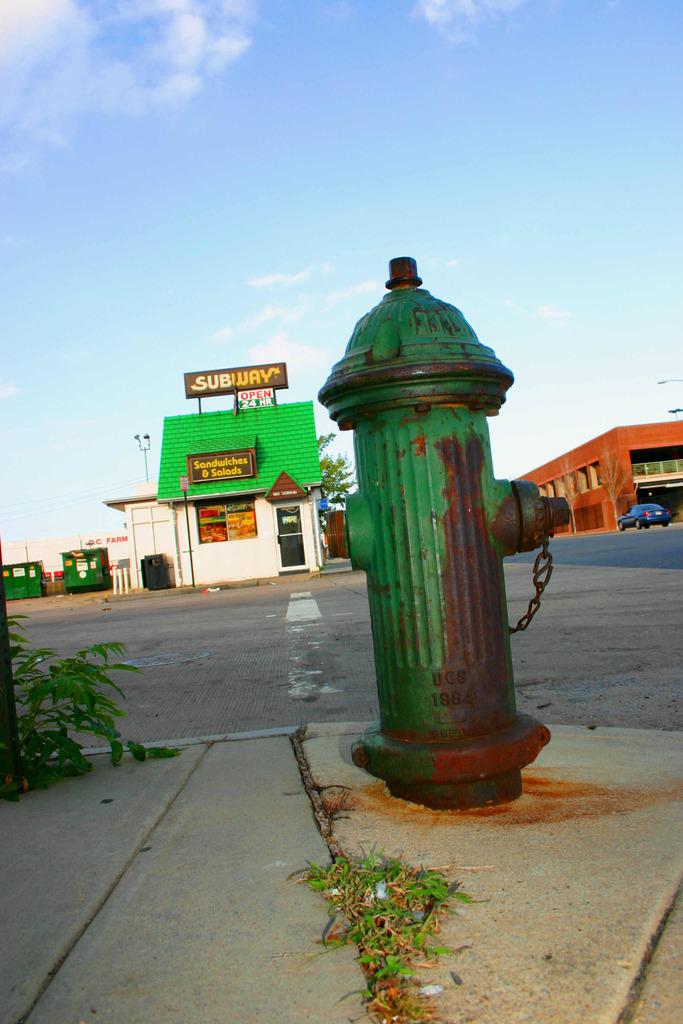What does the billboard say?
Keep it short and to the point. Subway. What does the establishment serve?
Offer a terse response. Sandwiches and salads. 